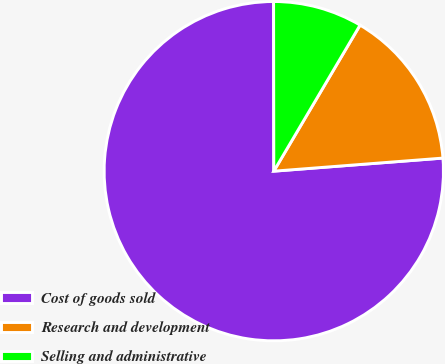<chart> <loc_0><loc_0><loc_500><loc_500><pie_chart><fcel>Cost of goods sold<fcel>Research and development<fcel>Selling and administrative<nl><fcel>76.21%<fcel>15.28%<fcel>8.51%<nl></chart> 